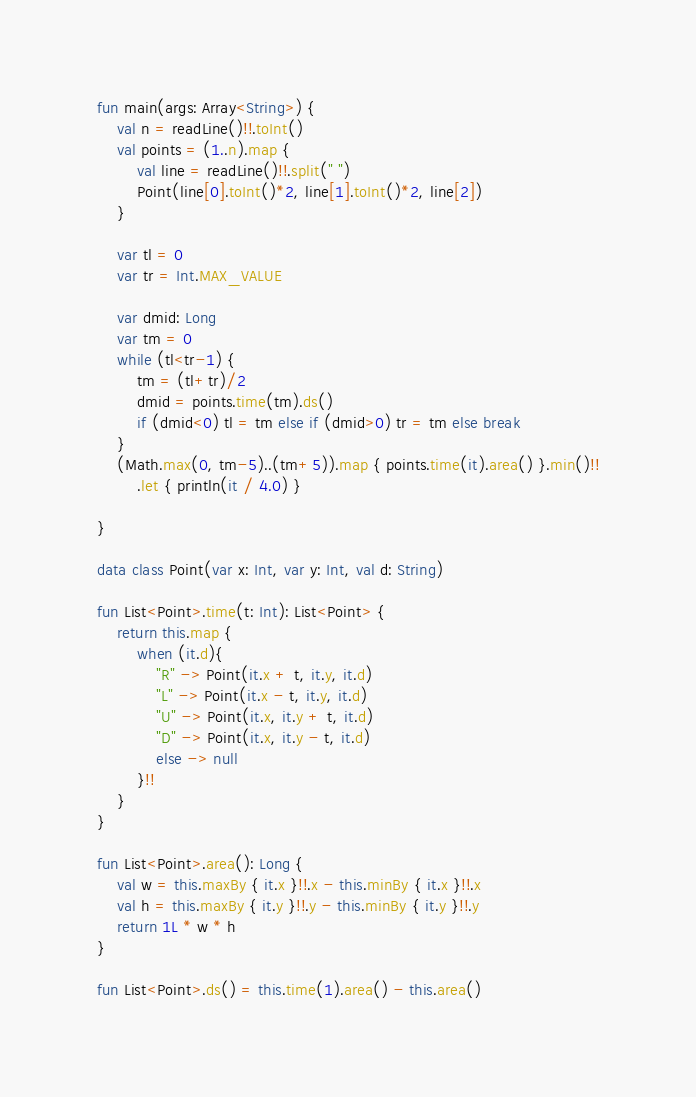<code> <loc_0><loc_0><loc_500><loc_500><_Kotlin_>fun main(args: Array<String>) {
    val n = readLine()!!.toInt()
    val points = (1..n).map {
        val line = readLine()!!.split(" ")
        Point(line[0].toInt()*2, line[1].toInt()*2, line[2])
    }
    
    var tl = 0
    var tr = Int.MAX_VALUE

    var dmid: Long
    var tm = 0
    while (tl<tr-1) {
        tm = (tl+tr)/2
        dmid = points.time(tm).ds()
        if (dmid<0) tl = tm else if (dmid>0) tr = tm else break
    }
    (Math.max(0, tm-5)..(tm+5)).map { points.time(it).area() }.min()!!
        .let { println(it / 4.0) }

}

data class Point(var x: Int, var y: Int, val d: String)

fun List<Point>.time(t: Int): List<Point> {
    return this.map {
        when (it.d){
            "R" -> Point(it.x + t, it.y, it.d)
            "L" -> Point(it.x - t, it.y, it.d)
            "U" -> Point(it.x, it.y + t, it.d)
            "D" -> Point(it.x, it.y - t, it.d)
            else -> null
        }!!
    }
}

fun List<Point>.area(): Long {
    val w = this.maxBy { it.x }!!.x - this.minBy { it.x }!!.x
    val h = this.maxBy { it.y }!!.y - this.minBy { it.y }!!.y
    return 1L * w * h
}

fun List<Point>.ds() = this.time(1).area() - this.area()</code> 